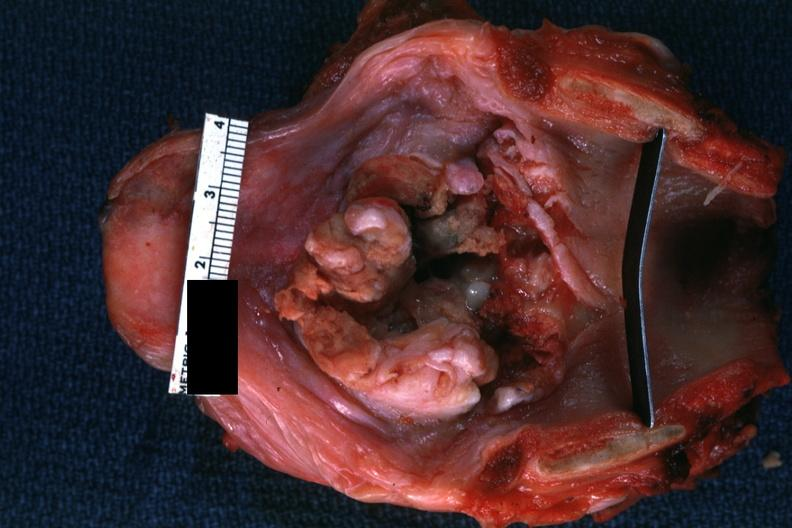what is present?
Answer the question using a single word or phrase. Carcinoma 